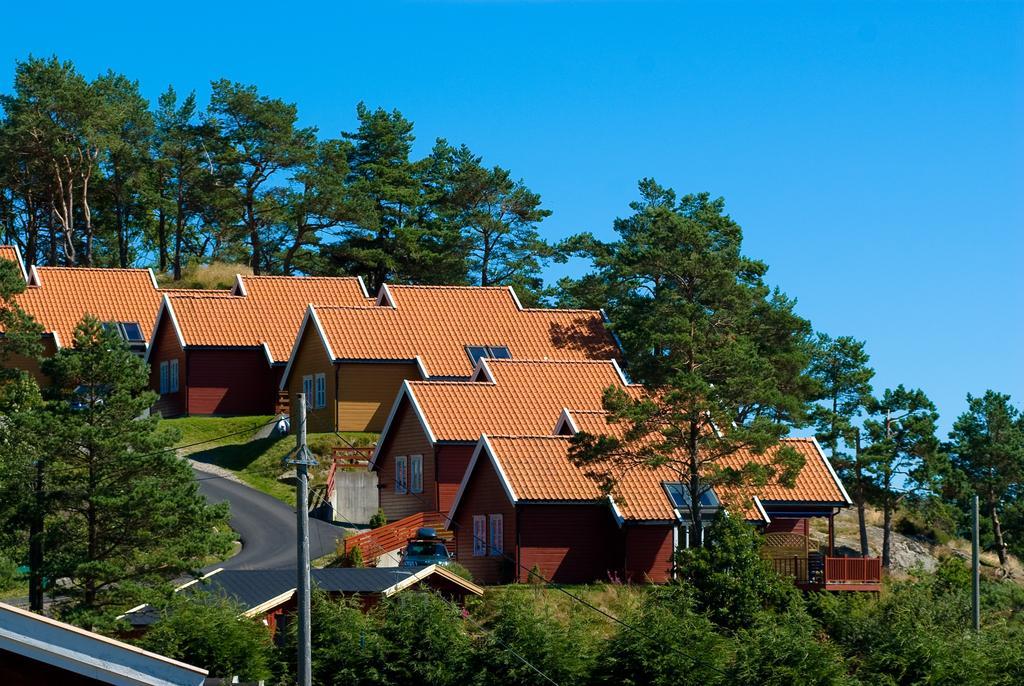Please provide a concise description of this image. In this picture I can see number of trees, houses, few poles, wires and the road in front. In the background I can see the sky. 